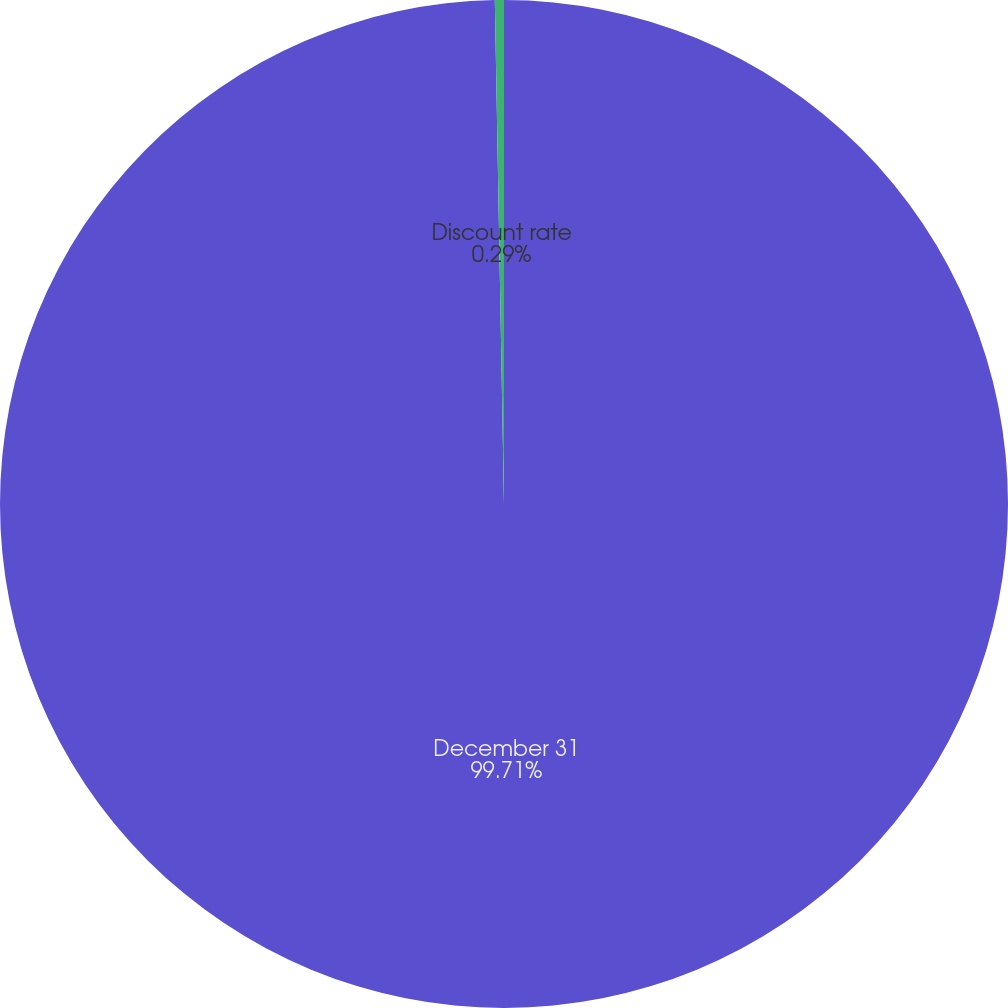Convert chart. <chart><loc_0><loc_0><loc_500><loc_500><pie_chart><fcel>December 31<fcel>Discount rate<nl><fcel>99.71%<fcel>0.29%<nl></chart> 